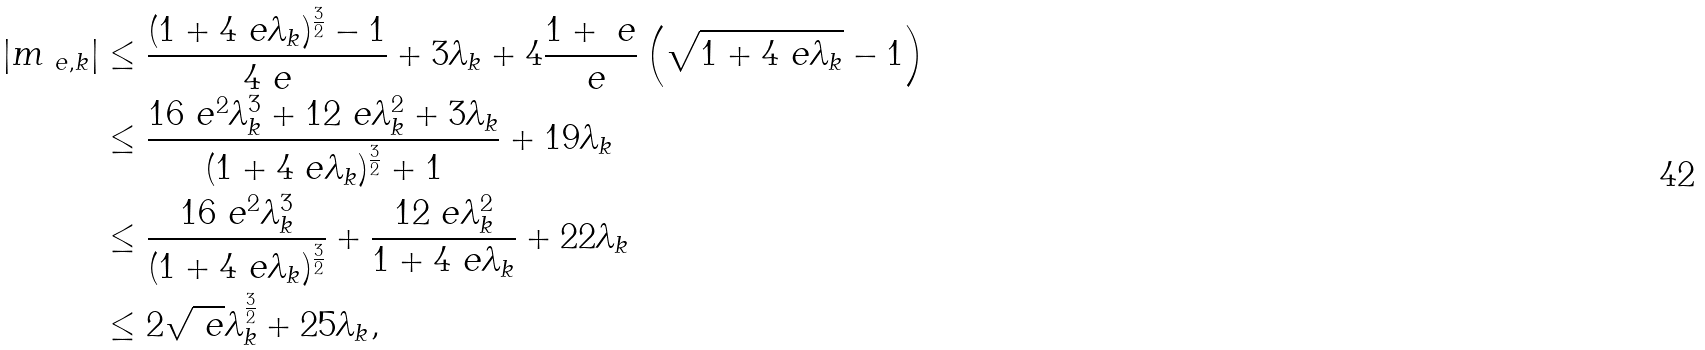<formula> <loc_0><loc_0><loc_500><loc_500>| m _ { \ e , k } | & \leq \frac { ( 1 + 4 \ e \lambda _ { k } ) ^ { \frac { 3 } { 2 } } - 1 } { 4 \ e } + 3 \lambda _ { k } + 4 \frac { 1 + \ e } { \ e } \left ( \sqrt { 1 + 4 \ e \lambda _ { k } } - 1 \right ) \\ & \leq \frac { 1 6 \ e ^ { 2 } \lambda _ { k } ^ { 3 } + 1 2 \ e \lambda _ { k } ^ { 2 } + 3 \lambda _ { k } } { ( 1 + 4 \ e \lambda _ { k } ) ^ { \frac { 3 } { 2 } } + 1 } + 1 9 \lambda _ { k } \\ & \leq \frac { 1 6 \ e ^ { 2 } \lambda _ { k } ^ { 3 } } { ( 1 + 4 \ e \lambda _ { k } ) ^ { \frac { 3 } { 2 } } } + \frac { 1 2 \ e \lambda _ { k } ^ { 2 } } { 1 + 4 \ e \lambda _ { k } } + 2 2 \lambda _ { k } \\ & \leq 2 \sqrt { \ e } \lambda _ { k } ^ { \frac { 3 } { 2 } } + 2 5 \lambda _ { k } ,</formula> 